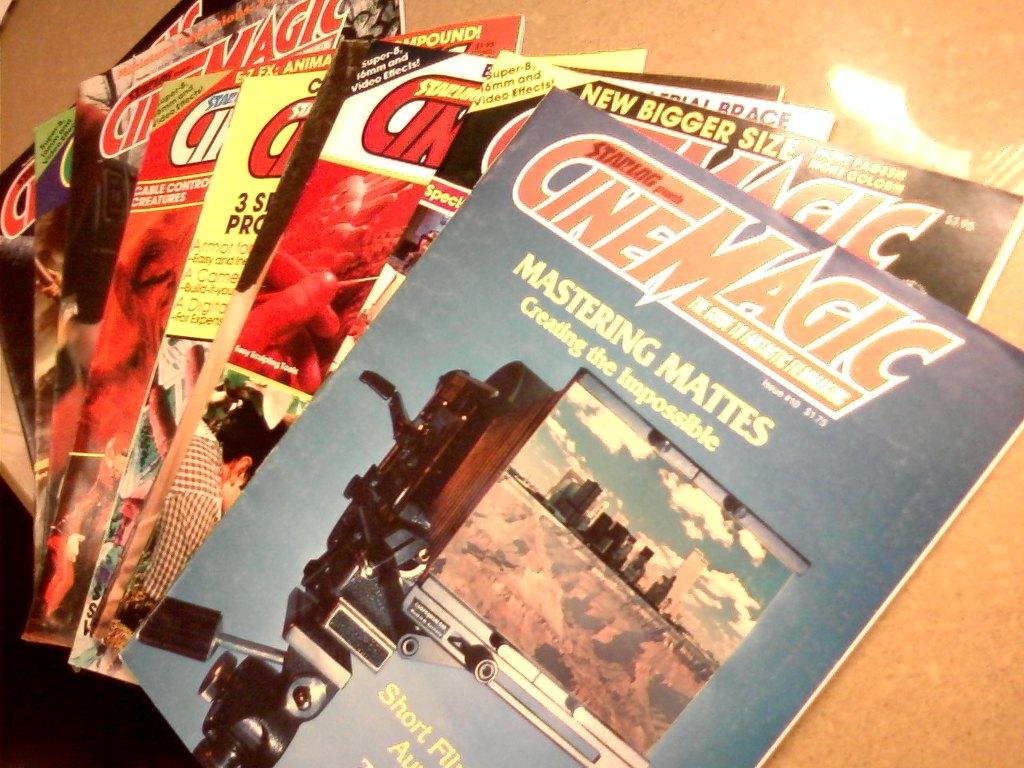What publication does mastering mattes belong to?
Your response must be concise. Cinemagic. What is this magizine trying to create?
Ensure brevity in your answer.  The impossible. 